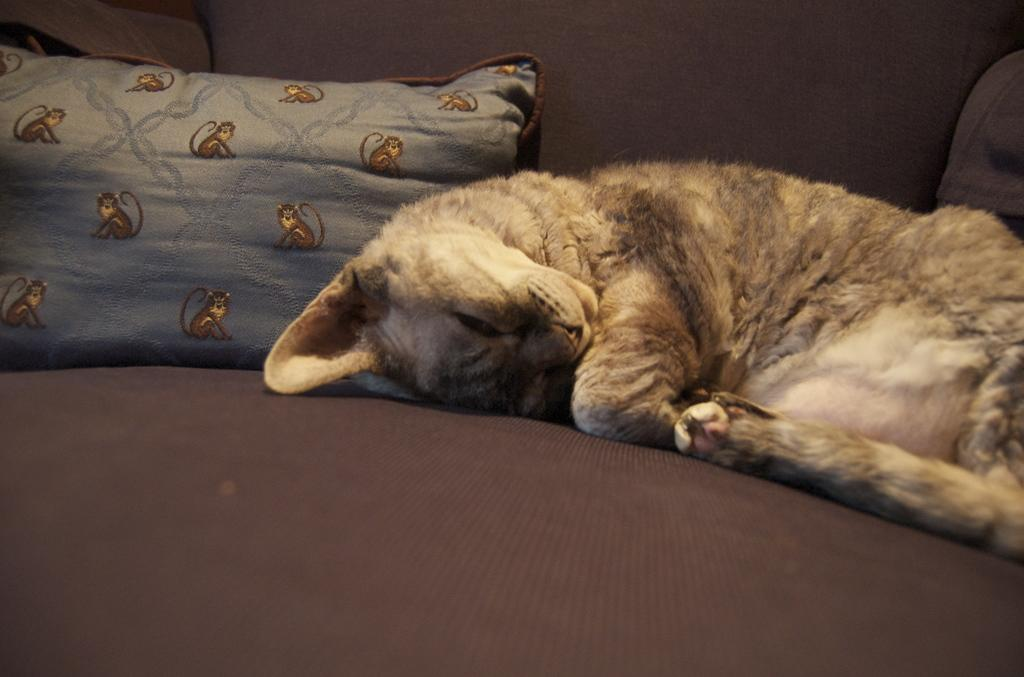What type of furniture is present in the image? There is a couch in the image. What is placed on the couch? There is a pillow on the couch. What animal can be seen on the couch? A cat is lying on the couch. What type of horn is visible on the cat in the image? There is no horn present on the cat in the image. 